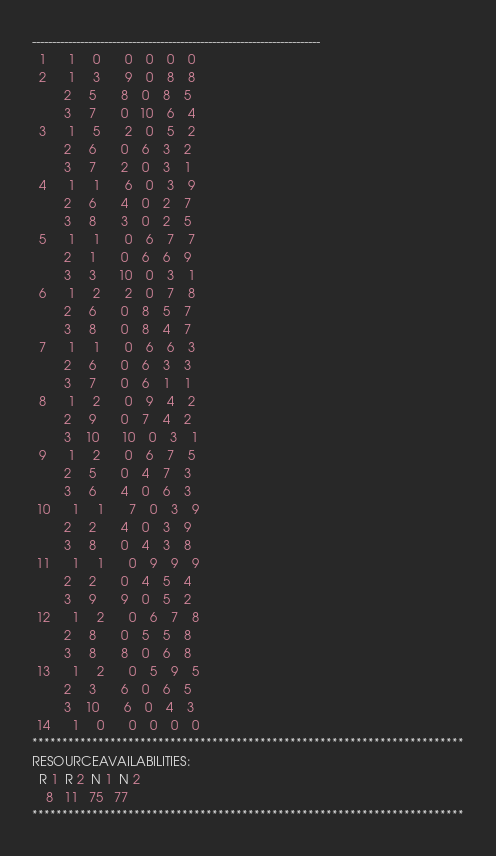Convert code to text. <code><loc_0><loc_0><loc_500><loc_500><_ObjectiveC_>------------------------------------------------------------------------
  1      1     0       0    0    0    0
  2      1     3       9    0    8    8
         2     5       8    0    8    5
         3     7       0   10    6    4
  3      1     5       2    0    5    2
         2     6       0    6    3    2
         3     7       2    0    3    1
  4      1     1       6    0    3    9
         2     6       4    0    2    7
         3     8       3    0    2    5
  5      1     1       0    6    7    7
         2     1       0    6    6    9
         3     3      10    0    3    1
  6      1     2       2    0    7    8
         2     6       0    8    5    7
         3     8       0    8    4    7
  7      1     1       0    6    6    3
         2     6       0    6    3    3
         3     7       0    6    1    1
  8      1     2       0    9    4    2
         2     9       0    7    4    2
         3    10      10    0    3    1
  9      1     2       0    6    7    5
         2     5       0    4    7    3
         3     6       4    0    6    3
 10      1     1       7    0    3    9
         2     2       4    0    3    9
         3     8       0    4    3    8
 11      1     1       0    9    9    9
         2     2       0    4    5    4
         3     9       9    0    5    2
 12      1     2       0    6    7    8
         2     8       0    5    5    8
         3     8       8    0    6    8
 13      1     2       0    5    9    5
         2     3       6    0    6    5
         3    10       6    0    4    3
 14      1     0       0    0    0    0
************************************************************************
RESOURCEAVAILABILITIES:
  R 1  R 2  N 1  N 2
    8   11   75   77
************************************************************************
</code> 